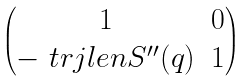<formula> <loc_0><loc_0><loc_500><loc_500>\begin{pmatrix} 1 & 0 \\ - \ t r j l e n S ^ { \prime \prime } ( q ) & 1 \end{pmatrix}</formula> 